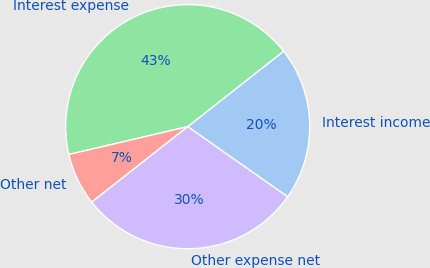Convert chart. <chart><loc_0><loc_0><loc_500><loc_500><pie_chart><fcel>Interest income<fcel>Interest expense<fcel>Other net<fcel>Other expense net<nl><fcel>20.35%<fcel>43.05%<fcel>6.95%<fcel>29.65%<nl></chart> 